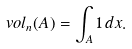<formula> <loc_0><loc_0><loc_500><loc_500>\ v o l _ { n } ( A ) = \int _ { A } 1 \, d x .</formula> 